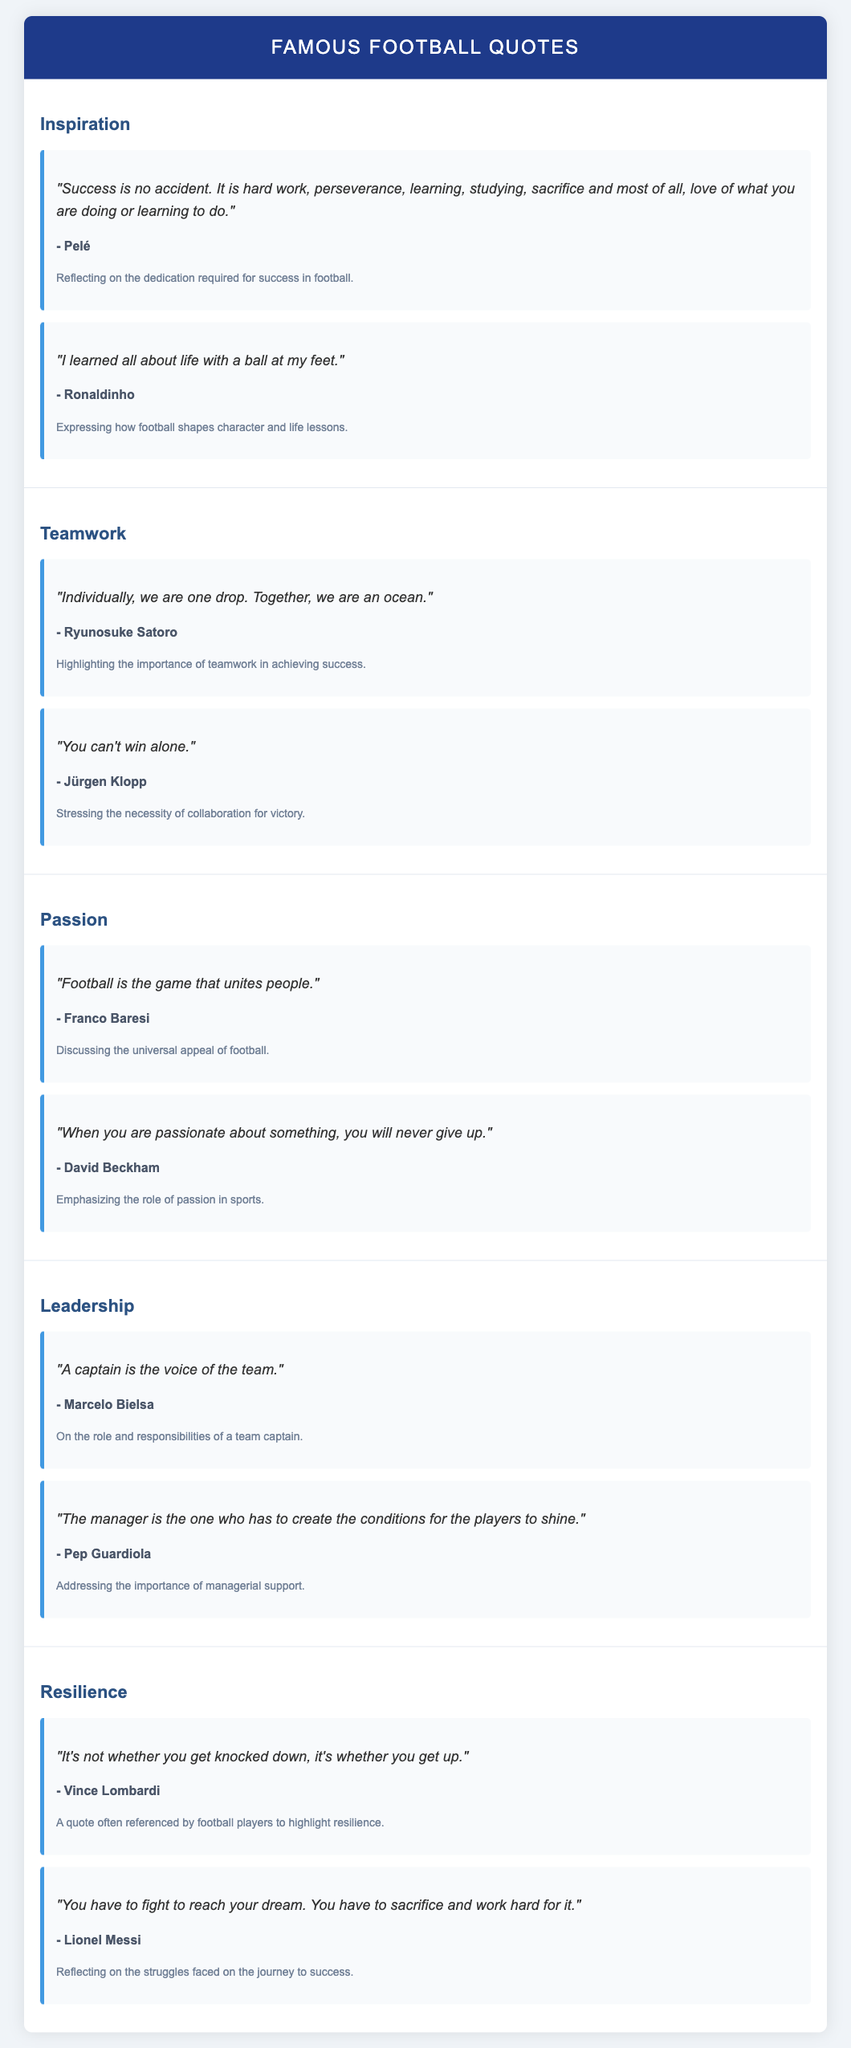What is the title of the document? The title is found in the header of the document, indicating the subject matter.
Answer: Famous Football Quotes Who is the author of the quote about hard work and success? The author is identified in the quote card discussing dedication and success.
Answer: Pelé Which theme includes a quote about teamwork? The themes are categorized in sections, and one of them is specifically about teamwork.
Answer: Teamwork What is the context provided for Ronaldinho's quote? The context describes how football influences personal growth and life lessons.
Answer: Expressing how football shapes character and life lessons How many quotes are listed under the passion theme? The document specifies the number of quotes in each themed section.
Answer: 2 Who quoted "You can't win alone"? This specific quote is attributed to a well-known football personality featured in the teamwork section.
Answer: Jürgen Klopp What does Marcelo Bielsa say a captain represents? The quote conveys the role and significance of captains in a football team setting.
Answer: The voice of the team Which quote emphasizes the importance of fighting for one's dreams? The quote reflects on effort and struggle tied to achieving dreams, specifically in football.
Answer: "You have to fight to reach your dream. You have to sacrifice and work hard for it." 